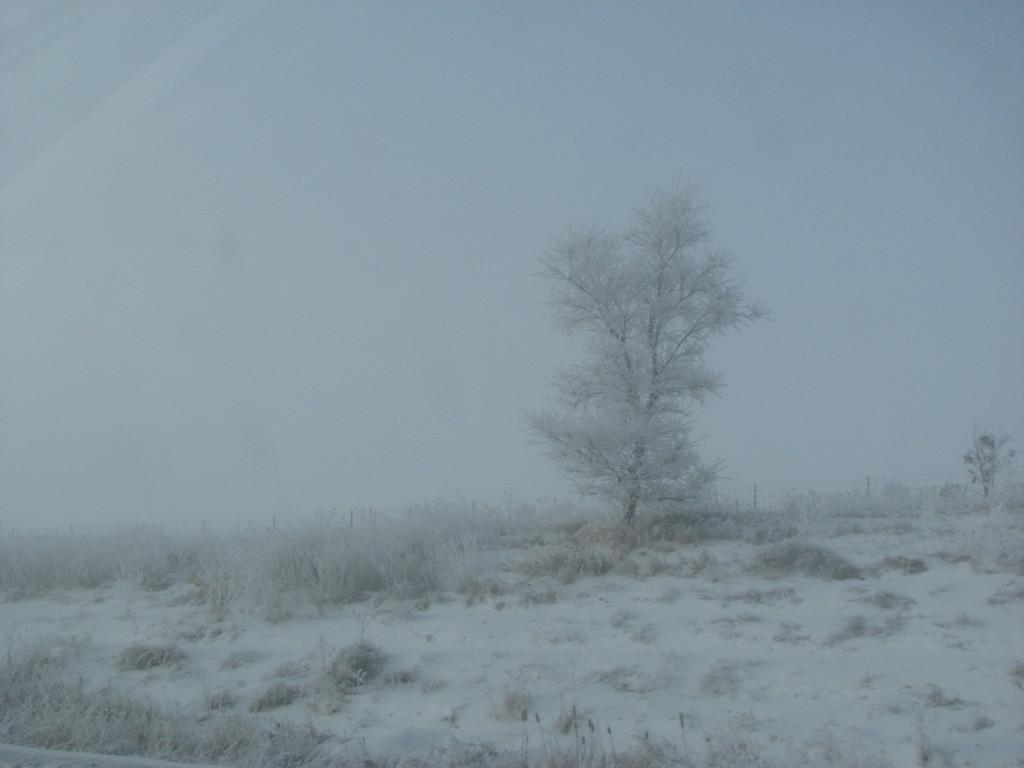What type of weather is depicted in the image? There is snow in the image, indicating a cold or wintry weather condition. What type of vegetation can be seen in the image? There is grass and trees visible in the image. What is located in the background of the image? There is a fence and the sky visible in the background of the image. What type of argument is taking place in the image? There is no argument present in the image; it depicts a snowy scene with grass, trees, a fence, and the sky. What sense is being stimulated by the calendar in the image? There is no calendar present in the image, so it cannot be used to stimulate any sense. 